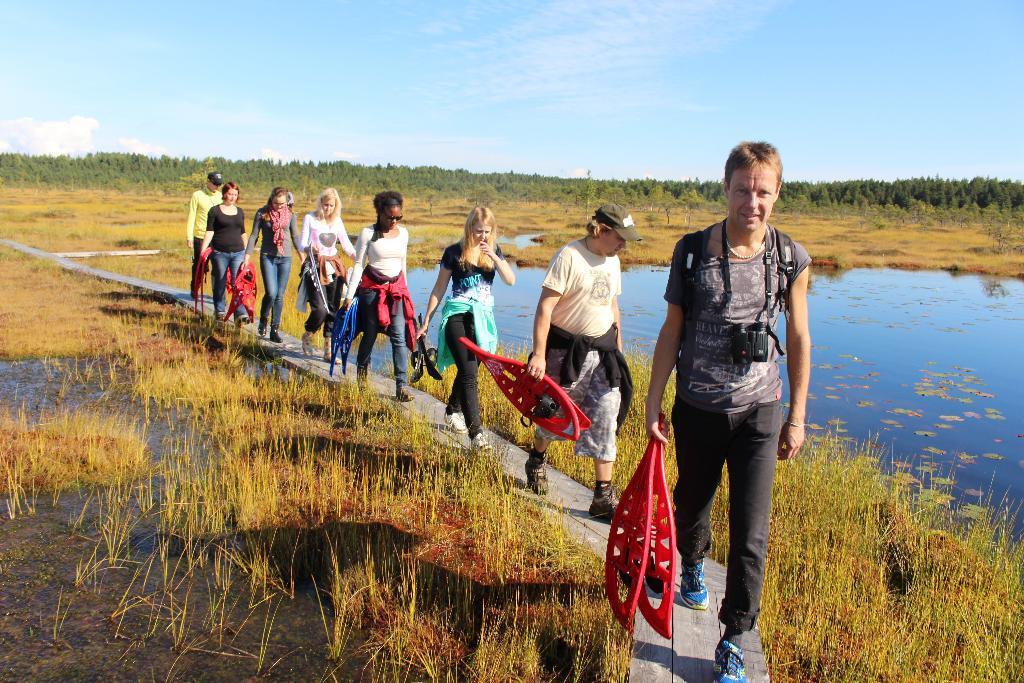In one or two sentences, can you explain what this image depicts? In the background we can see the sky. In this picture we can see the trees, field and water. We can see the people holding objects and walking on the wooden pathway. 